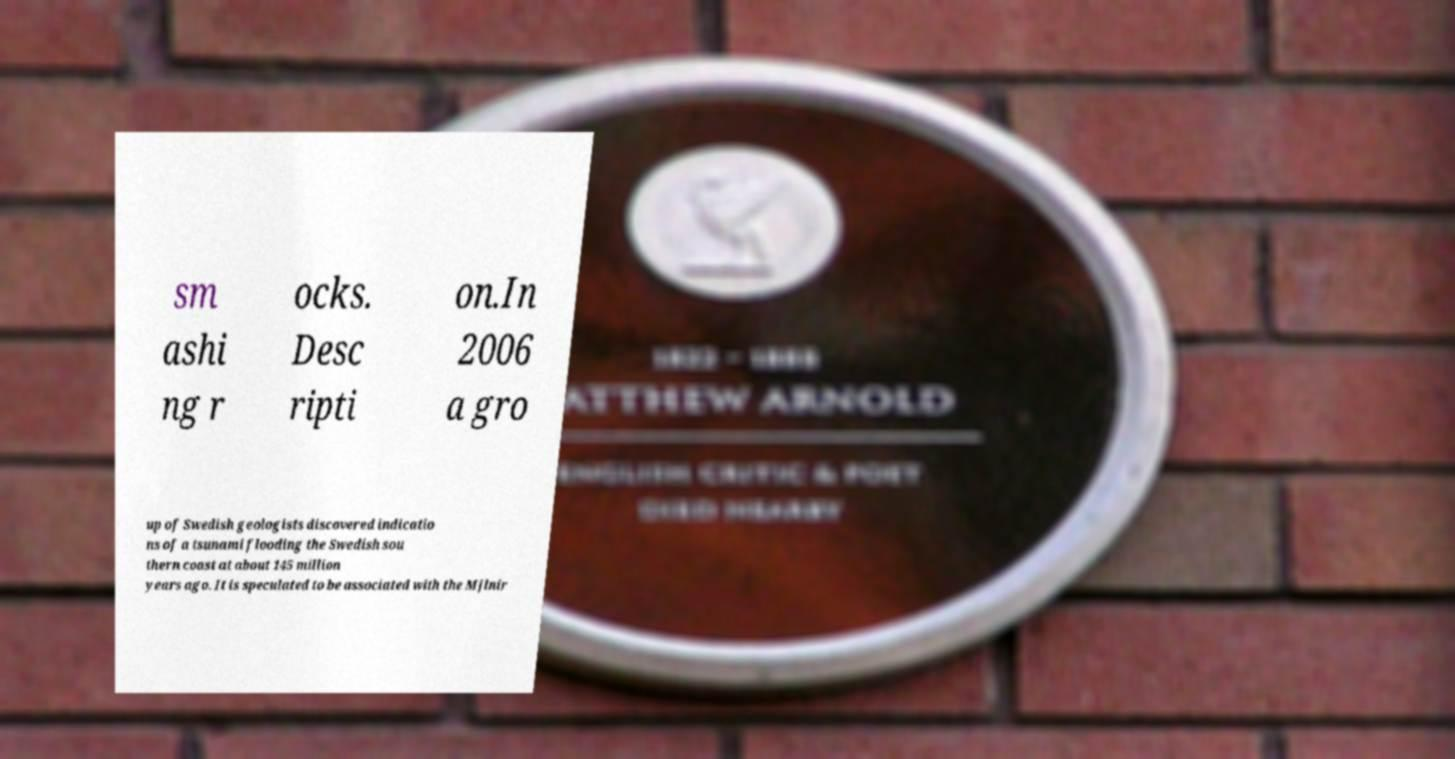Could you extract and type out the text from this image? sm ashi ng r ocks. Desc ripti on.In 2006 a gro up of Swedish geologists discovered indicatio ns of a tsunami flooding the Swedish sou thern coast at about 145 million years ago. It is speculated to be associated with the Mjlnir 